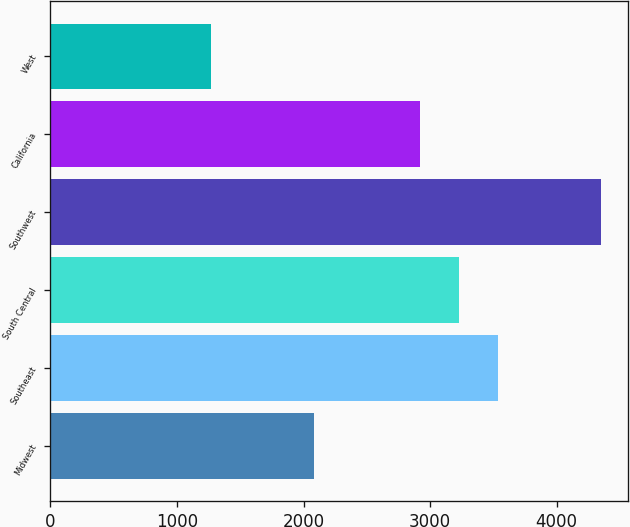<chart> <loc_0><loc_0><loc_500><loc_500><bar_chart><fcel>Midwest<fcel>Southeast<fcel>South Central<fcel>Southwest<fcel>California<fcel>West<nl><fcel>2080<fcel>3538.6<fcel>3230.3<fcel>4349<fcel>2922<fcel>1266<nl></chart> 